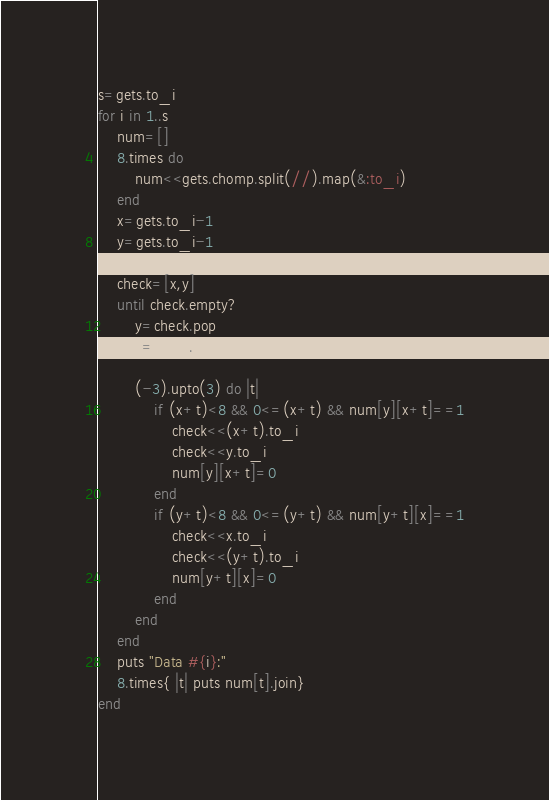Convert code to text. <code><loc_0><loc_0><loc_500><loc_500><_Ruby_>s=gets.to_i
for i in 1..s
    num=[]
    8.times do
        num<<gets.chomp.split(//).map(&:to_i)
    end
    x=gets.to_i-1
    y=gets.to_i-1
    
    check=[x,y]
    until check.empty?
        y=check.pop
        x=check.pop
        
        (-3).upto(3) do |t|
            if (x+t)<8 && 0<=(x+t) && num[y][x+t]==1
                check<<(x+t).to_i
                check<<y.to_i
                num[y][x+t]=0
            end
            if (y+t)<8 && 0<=(y+t) && num[y+t][x]==1
                check<<x.to_i
                check<<(y+t).to_i
                num[y+t][x]=0
            end
        end
    end
    puts "Data #{i}:"
    8.times{ |t| puts num[t].join}
end</code> 